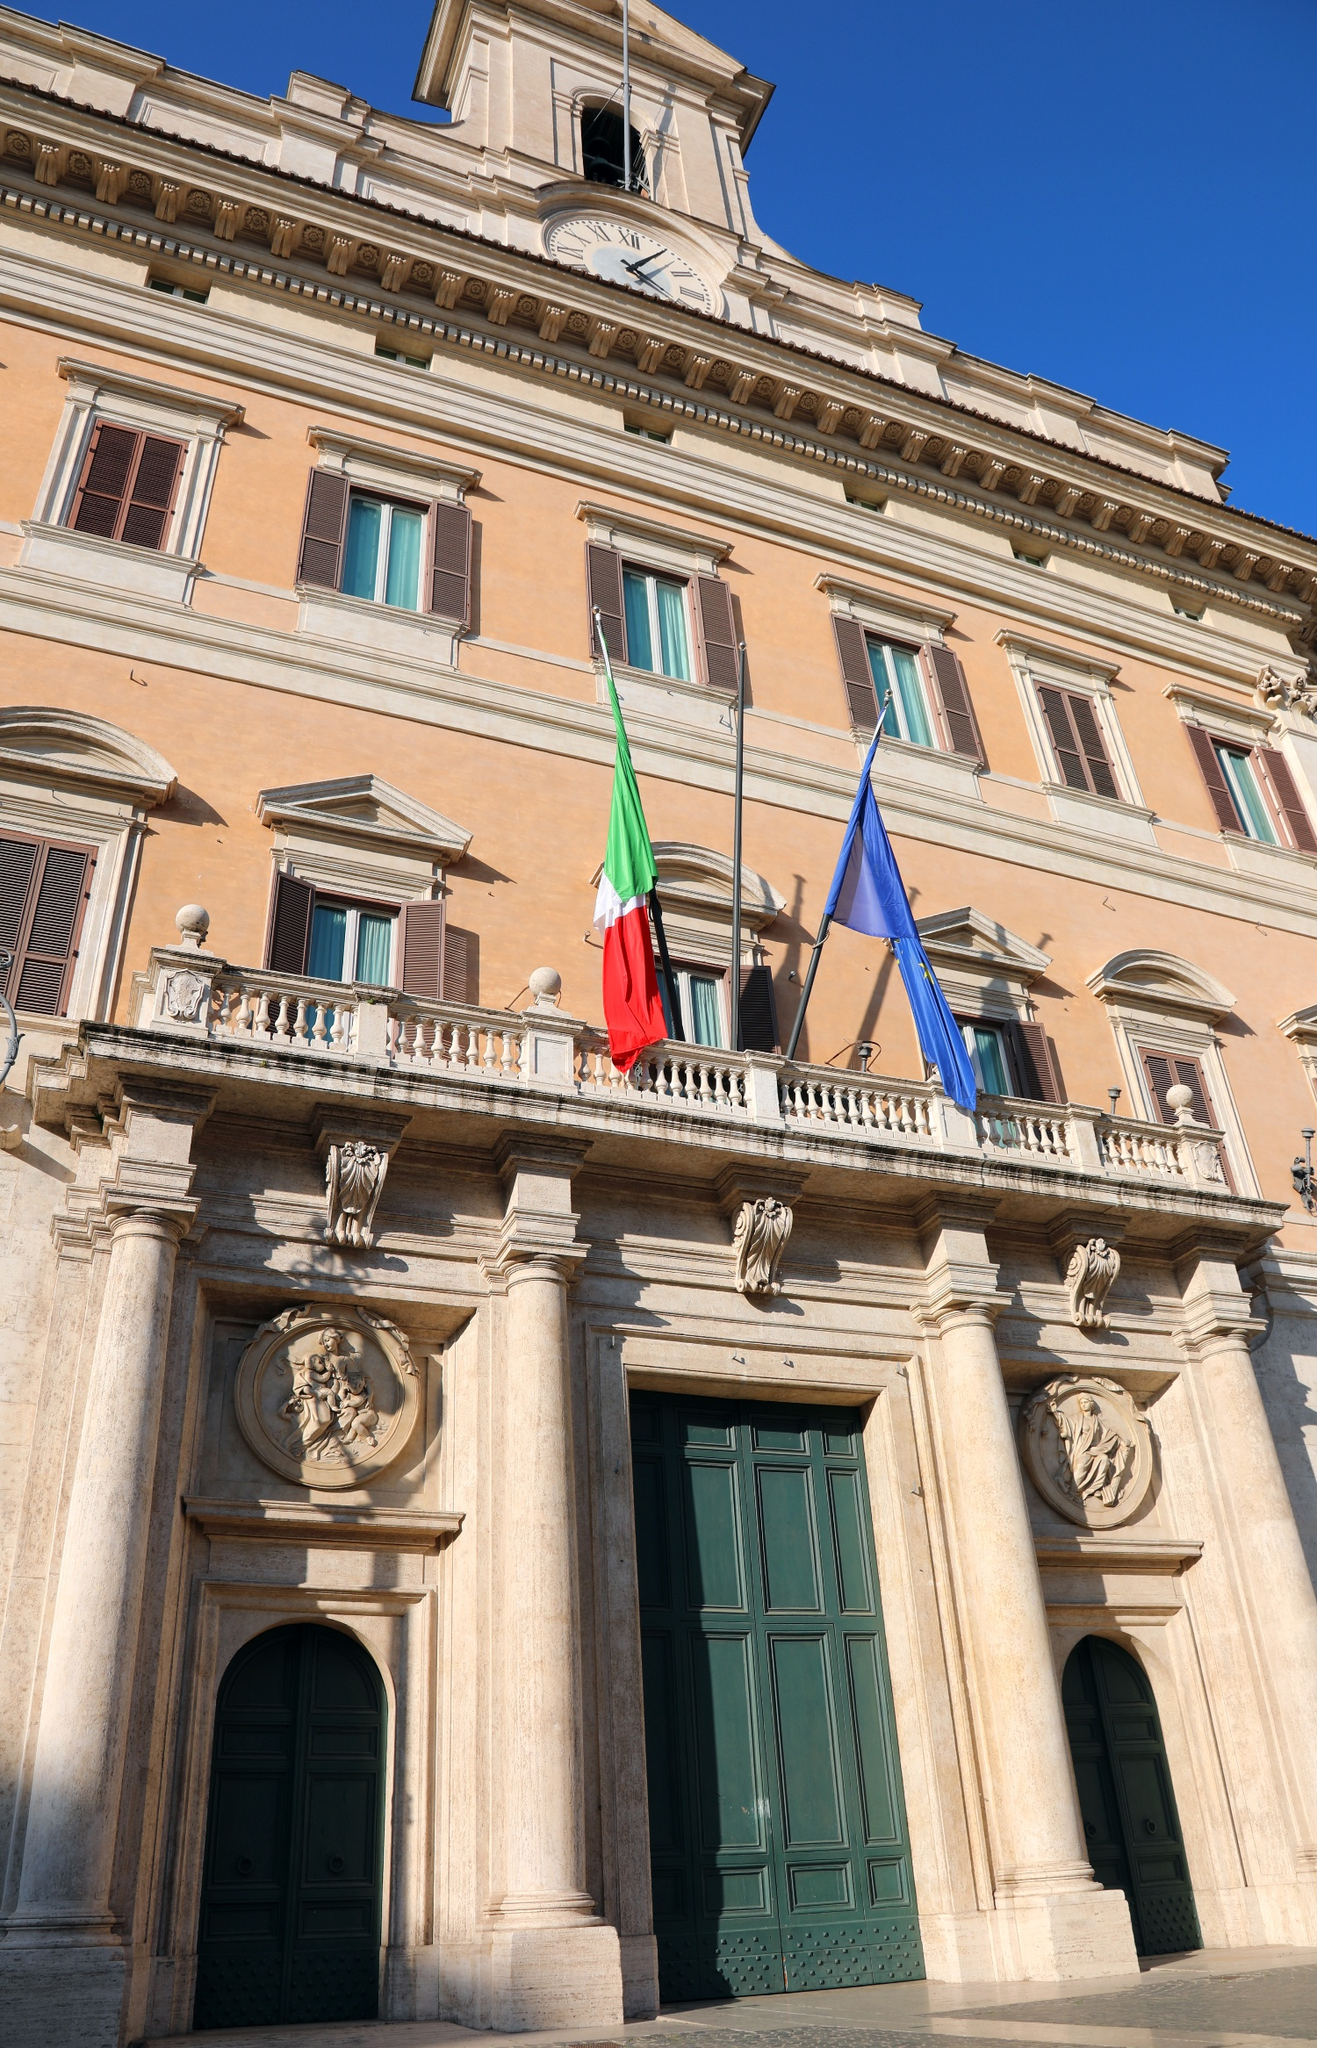What does the architecture of the building in the image symbolize? The architecture of Palazzo Montecitorio is rich in symbolism, reflecting ideals of order, strength, and governance, typical of Neoclassical architecture adapted here in a Baroque influence. The symmetrical layout and robust facade represent stability and resilience, while decorative elements like the clock tower suggest the perpetual nature of time and governance. The presence of national and EU flags further emphasizes Italy's democratic heritage and its commitment to European integration. 